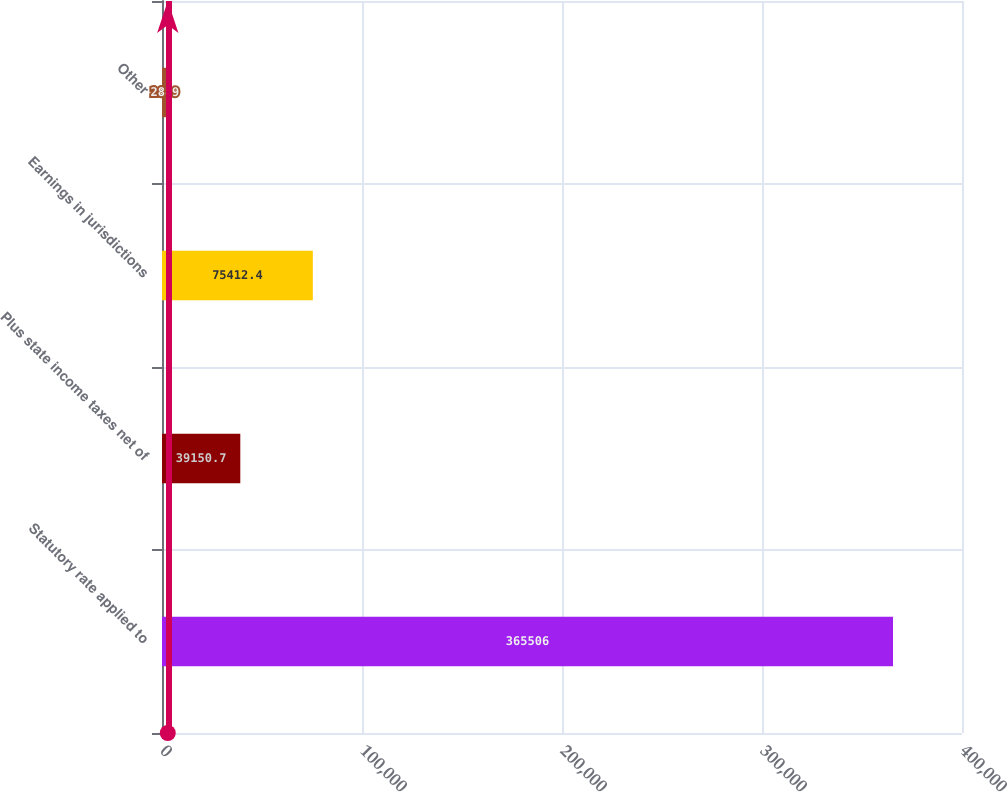<chart> <loc_0><loc_0><loc_500><loc_500><bar_chart><fcel>Statutory rate applied to<fcel>Plus state income taxes net of<fcel>Earnings in jurisdictions<fcel>Other<nl><fcel>365506<fcel>39150.7<fcel>75412.4<fcel>2889<nl></chart> 